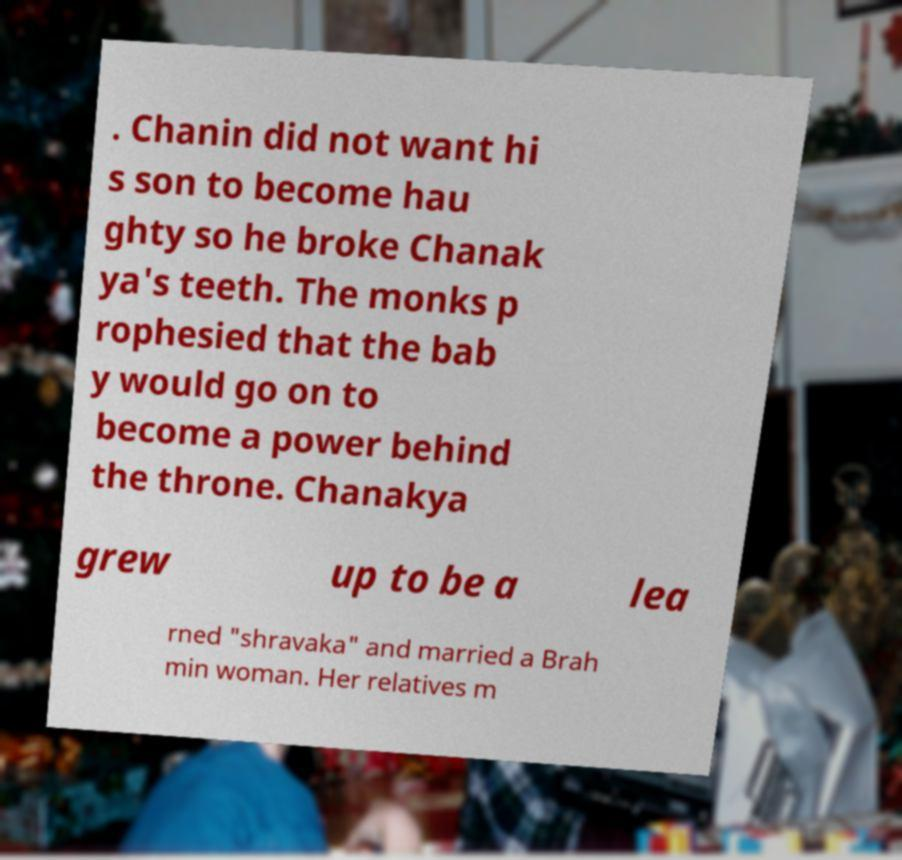Can you accurately transcribe the text from the provided image for me? . Chanin did not want hi s son to become hau ghty so he broke Chanak ya's teeth. The monks p rophesied that the bab y would go on to become a power behind the throne. Chanakya grew up to be a lea rned "shravaka" and married a Brah min woman. Her relatives m 